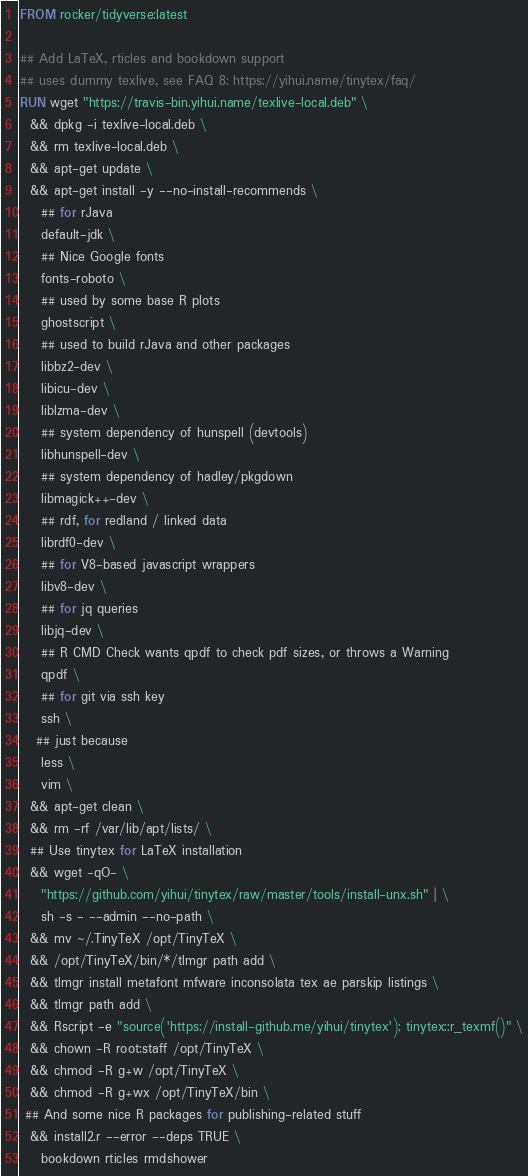<code> <loc_0><loc_0><loc_500><loc_500><_Dockerfile_>FROM rocker/tidyverse:latest

## Add LaTeX, rticles and bookdown support
## uses dummy texlive, see FAQ 8: https://yihui.name/tinytex/faq/
RUN wget "https://travis-bin.yihui.name/texlive-local.deb" \
  && dpkg -i texlive-local.deb \
  && rm texlive-local.deb \
  && apt-get update \
  && apt-get install -y --no-install-recommends \
    ## for rJava
    default-jdk \
    ## Nice Google fonts
    fonts-roboto \
    ## used by some base R plots
    ghostscript \
    ## used to build rJava and other packages
    libbz2-dev \
    libicu-dev \
    liblzma-dev \
    ## system dependency of hunspell (devtools)
    libhunspell-dev \
    ## system dependency of hadley/pkgdown
    libmagick++-dev \
    ## rdf, for redland / linked data
    librdf0-dev \
    ## for V8-based javascript wrappers
    libv8-dev \
    ## for jq queries
    libjq-dev \
    ## R CMD Check wants qpdf to check pdf sizes, or throws a Warning 
    qpdf \
    ## for git via ssh key 
    ssh \
   ## just because
    less \
    vim \
  && apt-get clean \
  && rm -rf /var/lib/apt/lists/ \
  ## Use tinytex for LaTeX installation
  && wget -qO- \
    "https://github.com/yihui/tinytex/raw/master/tools/install-unx.sh" | \
    sh -s - --admin --no-path \
  && mv ~/.TinyTeX /opt/TinyTeX \
  && /opt/TinyTeX/bin/*/tlmgr path add \
  && tlmgr install metafont mfware inconsolata tex ae parskip listings \
  && tlmgr path add \
  && Rscript -e "source('https://install-github.me/yihui/tinytex'); tinytex::r_texmf()" \
  && chown -R root:staff /opt/TinyTeX \
  && chmod -R g+w /opt/TinyTeX \
  && chmod -R g+wx /opt/TinyTeX/bin \
 ## And some nice R packages for publishing-related stuff
  && install2.r --error --deps TRUE \
    bookdown rticles rmdshower

</code> 